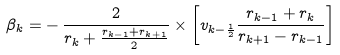<formula> <loc_0><loc_0><loc_500><loc_500>\beta _ { k } = - \, \frac { 2 } { r _ { k } + \frac { r _ { k - 1 } + r _ { k + 1 } } { 2 } } \times \left [ v _ { k - \frac { 1 } { 2 } } \frac { r _ { k - 1 } + r _ { k } } { r _ { k + 1 } - r _ { k - 1 } } \right ]</formula> 